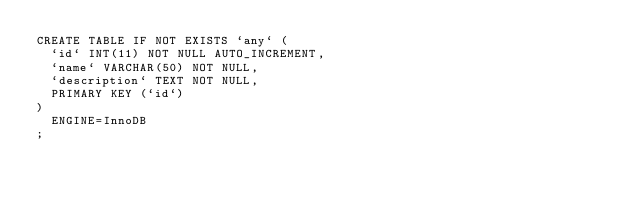<code> <loc_0><loc_0><loc_500><loc_500><_SQL_>CREATE TABLE IF NOT EXISTS `any` (
  `id` INT(11) NOT NULL AUTO_INCREMENT,
  `name` VARCHAR(50) NOT NULL,
  `description` TEXT NOT NULL,
  PRIMARY KEY (`id`)
)
  ENGINE=InnoDB
;</code> 